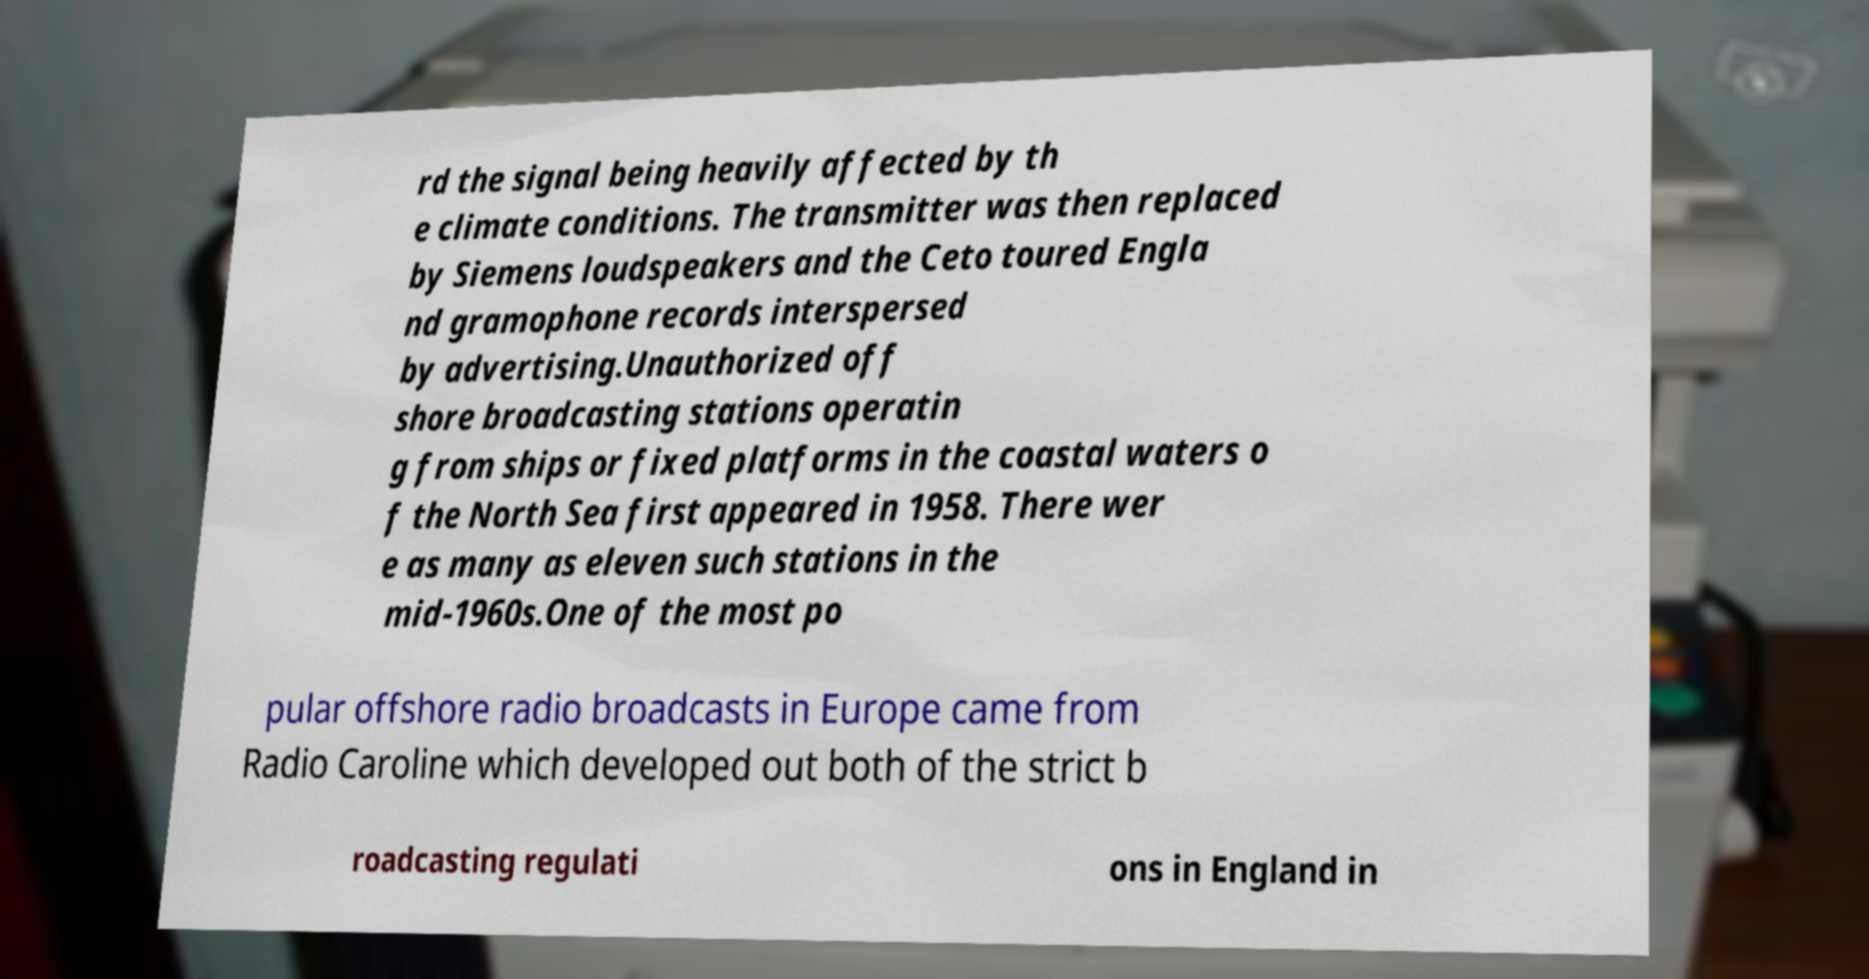For documentation purposes, I need the text within this image transcribed. Could you provide that? rd the signal being heavily affected by th e climate conditions. The transmitter was then replaced by Siemens loudspeakers and the Ceto toured Engla nd gramophone records interspersed by advertising.Unauthorized off shore broadcasting stations operatin g from ships or fixed platforms in the coastal waters o f the North Sea first appeared in 1958. There wer e as many as eleven such stations in the mid-1960s.One of the most po pular offshore radio broadcasts in Europe came from Radio Caroline which developed out both of the strict b roadcasting regulati ons in England in 